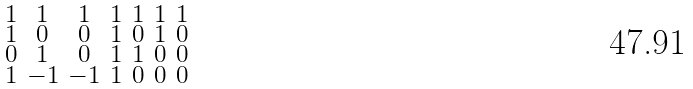Convert formula to latex. <formula><loc_0><loc_0><loc_500><loc_500>\begin{smallmatrix} 1 & 1 & 1 & 1 & 1 & 1 & 1 \\ 1 & 0 & 0 & 1 & 0 & 1 & 0 \\ 0 & 1 & 0 & 1 & 1 & 0 & 0 \\ 1 & - 1 & - 1 & 1 & 0 & 0 & 0 \end{smallmatrix}</formula> 